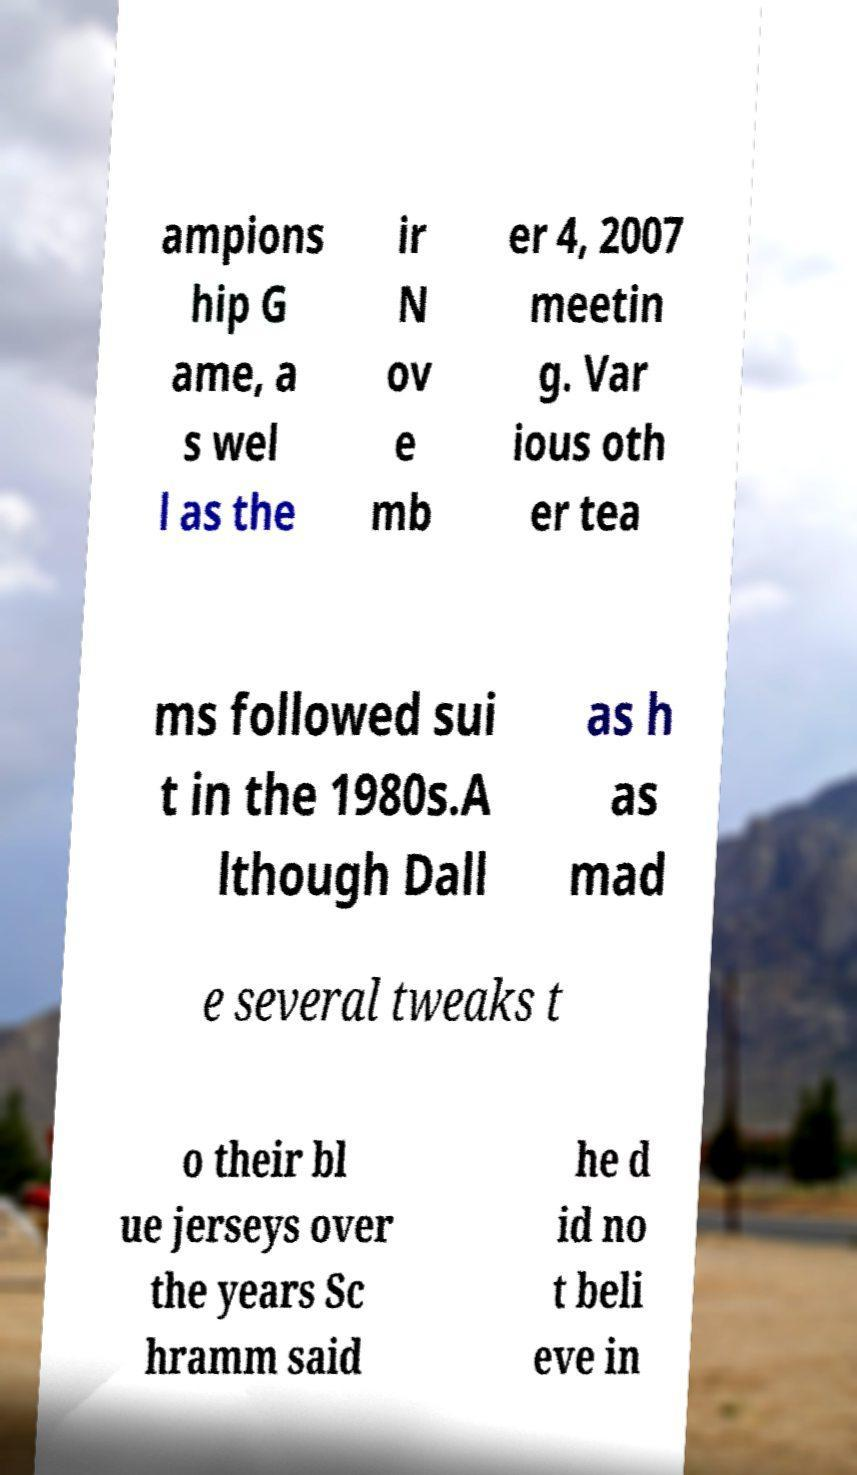For documentation purposes, I need the text within this image transcribed. Could you provide that? ampions hip G ame, a s wel l as the ir N ov e mb er 4, 2007 meetin g. Var ious oth er tea ms followed sui t in the 1980s.A lthough Dall as h as mad e several tweaks t o their bl ue jerseys over the years Sc hramm said he d id no t beli eve in 